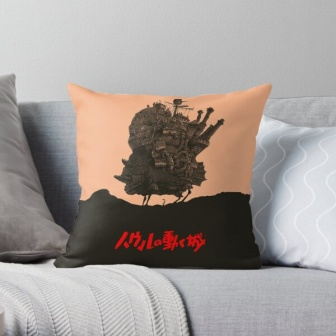How might the elements of this image reflect the personality of the person who owns this space? The elements of this image suggest that the person who owns this space values both comfort and creativity. The gray couch and blanket indicate a preference for a neutral, calming base, which contributes to a cozy and inviting atmosphere. The pillow, with its detailed and imaginative castle illustration coupled with the prominent 'Miyazaki' reference, reveals a love for fantasy and storytelling. It hints that the person might be a fan of animation and whimsical art, likely enjoying diving into fictional worlds where imagination reigns. The thoughtful arrangement and distinctive decor suggest that this person has a keen eye for design and enjoys curating a space that is both soothing and inspiring, a perfect environment for relaxation and creative thought. 